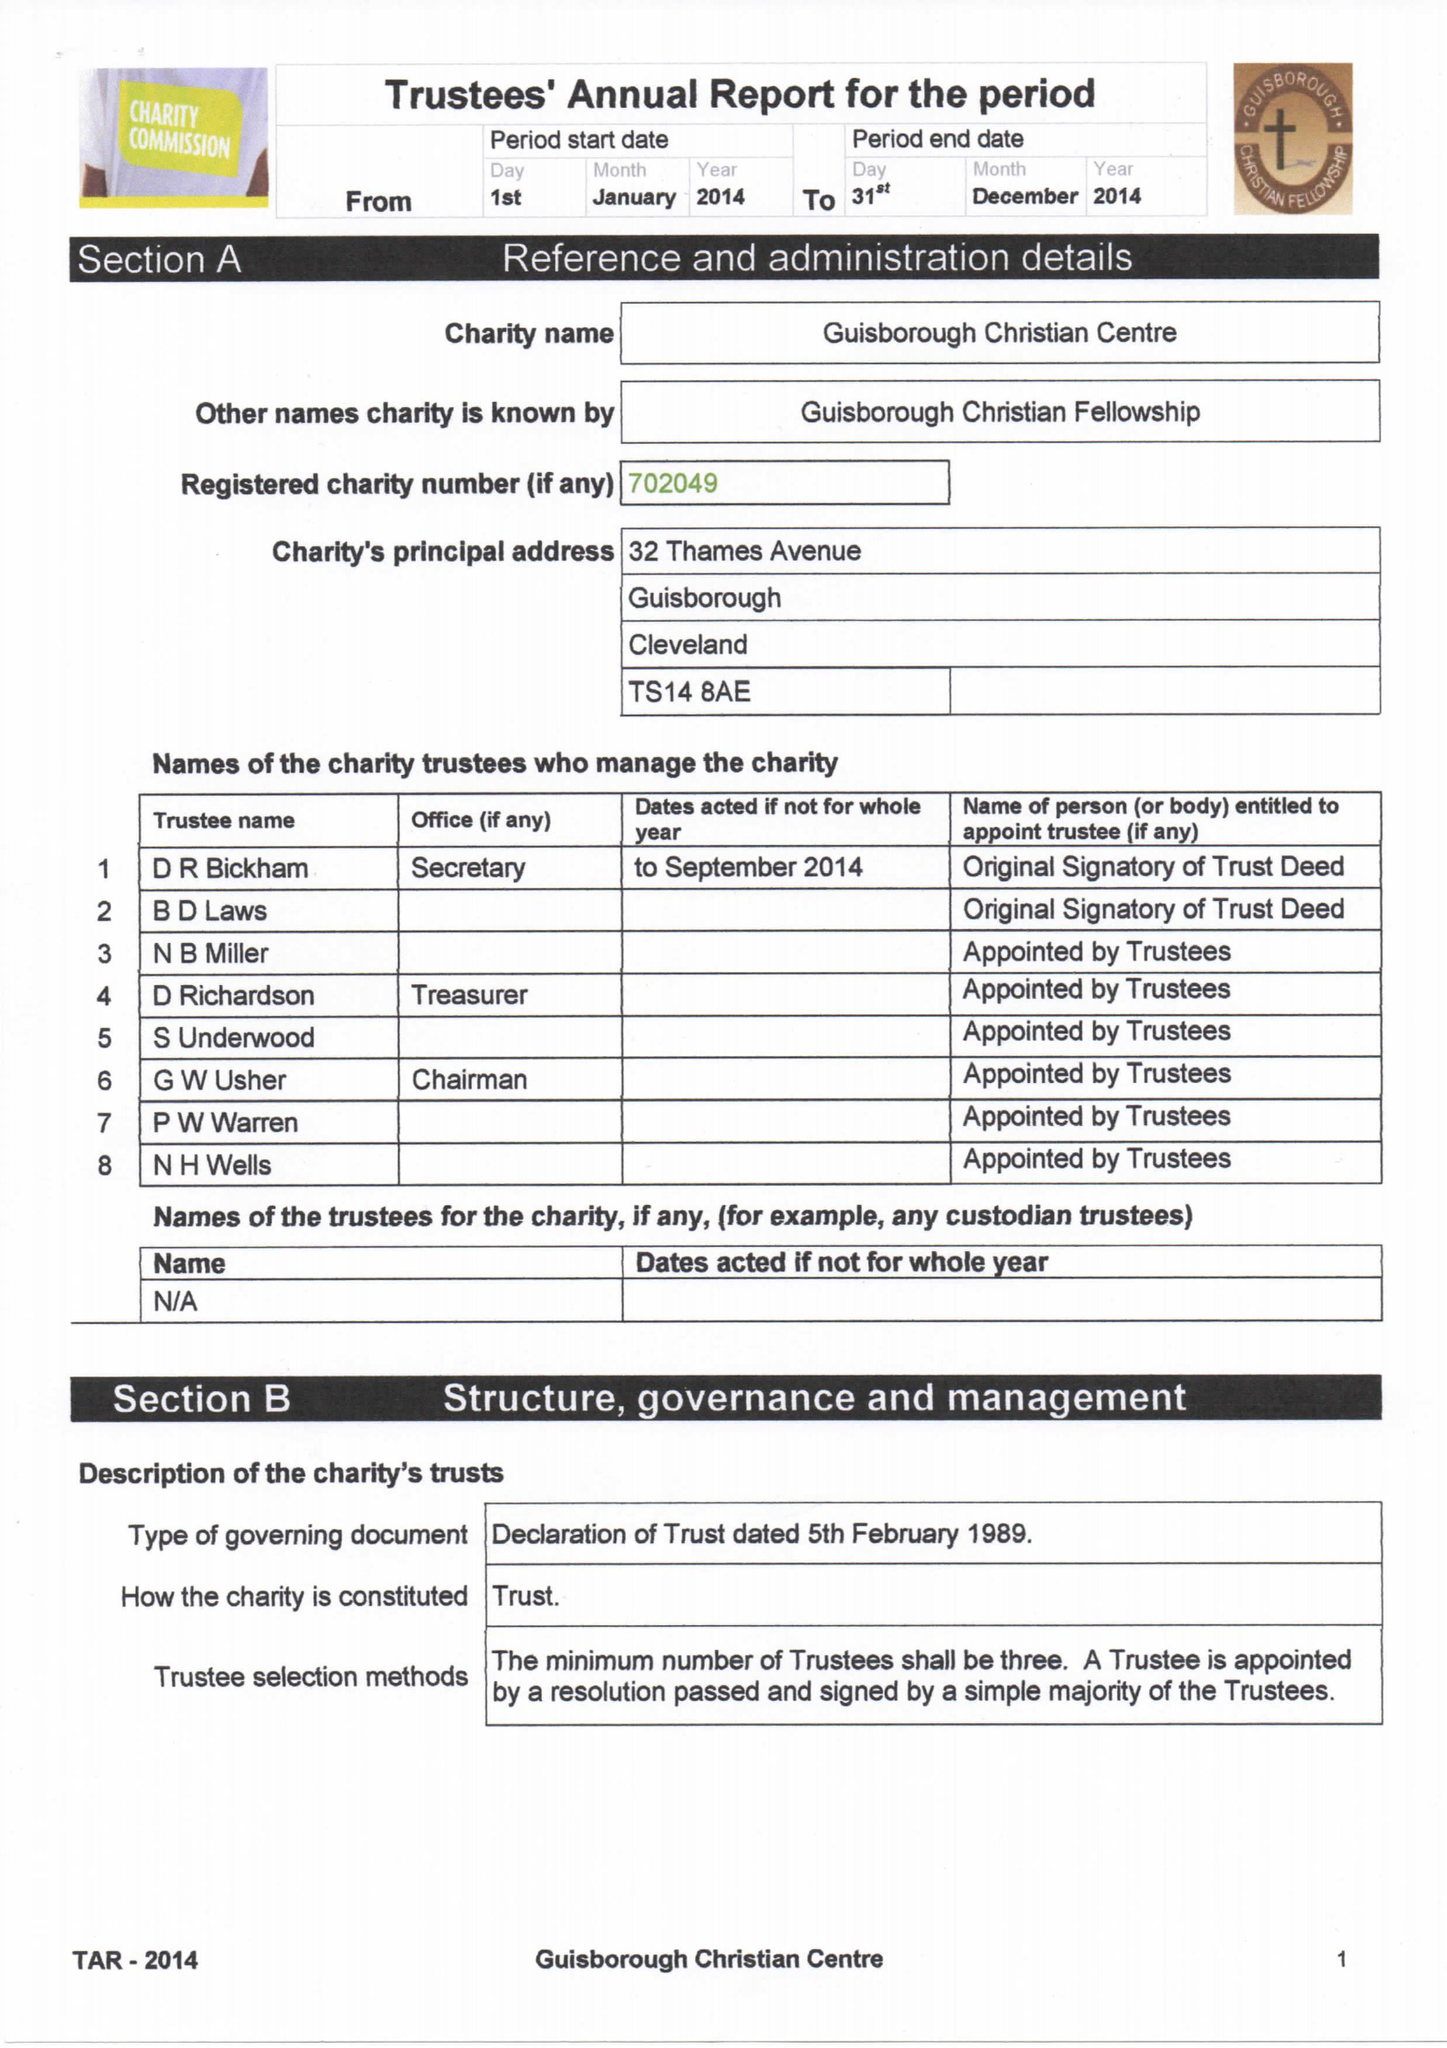What is the value for the charity_number?
Answer the question using a single word or phrase. 702049 